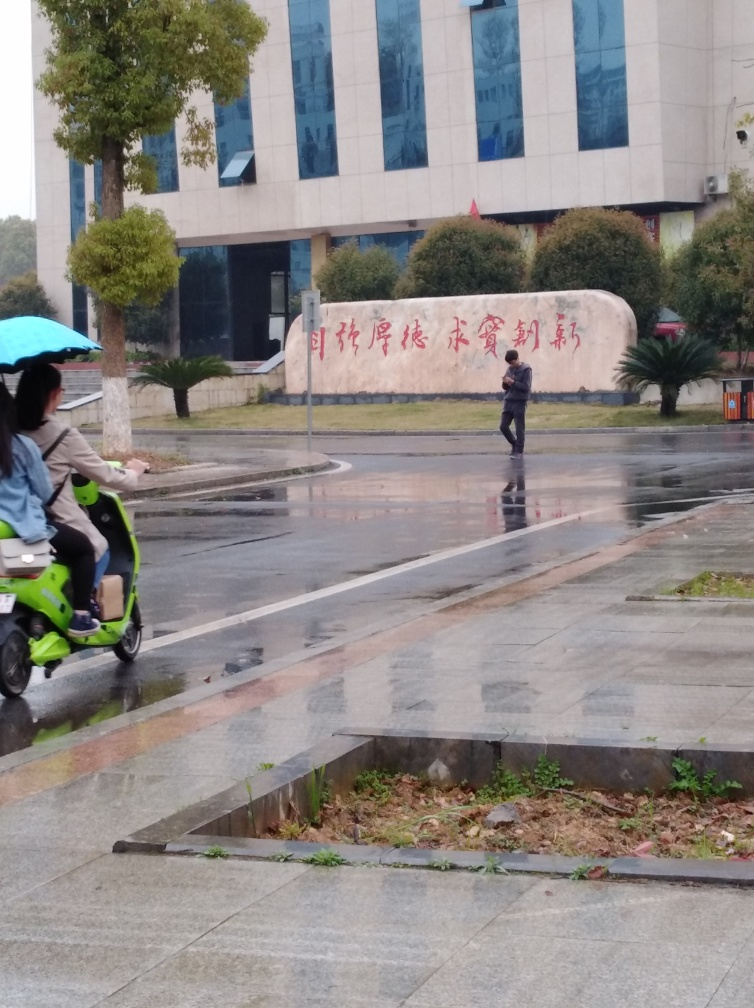Describe the mood and atmosphere this image conveys. The image conveys a quiet, somewhat somber atmosphere. The overcast sky, the rain-soaked streets, and the lone pedestrian create a sense of solitude. The muted colors and lack of sunlight bring about a calm, reflective mood, typical of a rainy day where activities are limited and people seek shelter. 